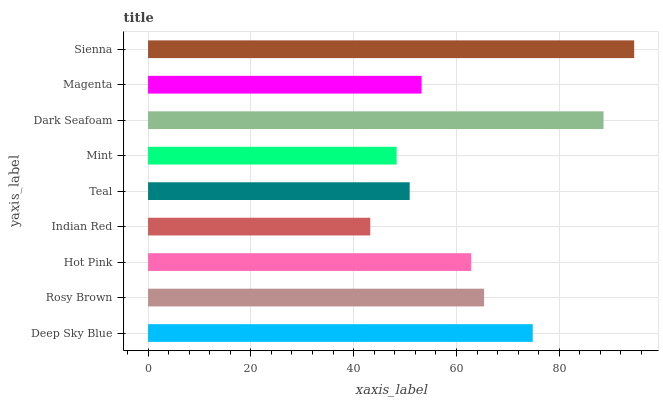Is Indian Red the minimum?
Answer yes or no. Yes. Is Sienna the maximum?
Answer yes or no. Yes. Is Rosy Brown the minimum?
Answer yes or no. No. Is Rosy Brown the maximum?
Answer yes or no. No. Is Deep Sky Blue greater than Rosy Brown?
Answer yes or no. Yes. Is Rosy Brown less than Deep Sky Blue?
Answer yes or no. Yes. Is Rosy Brown greater than Deep Sky Blue?
Answer yes or no. No. Is Deep Sky Blue less than Rosy Brown?
Answer yes or no. No. Is Hot Pink the high median?
Answer yes or no. Yes. Is Hot Pink the low median?
Answer yes or no. Yes. Is Sienna the high median?
Answer yes or no. No. Is Rosy Brown the low median?
Answer yes or no. No. 